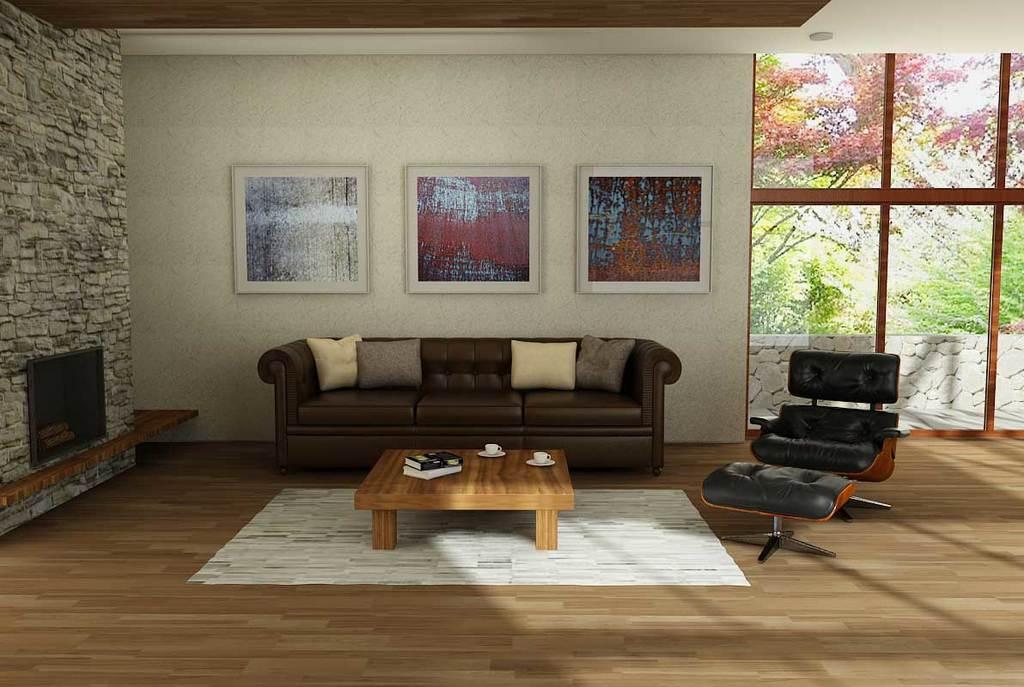Describe this image in one or two sentences. In this image I can see a sofa, a table, a television, two cups, two books and few frames on this wall. In the background I can see number of trees. 